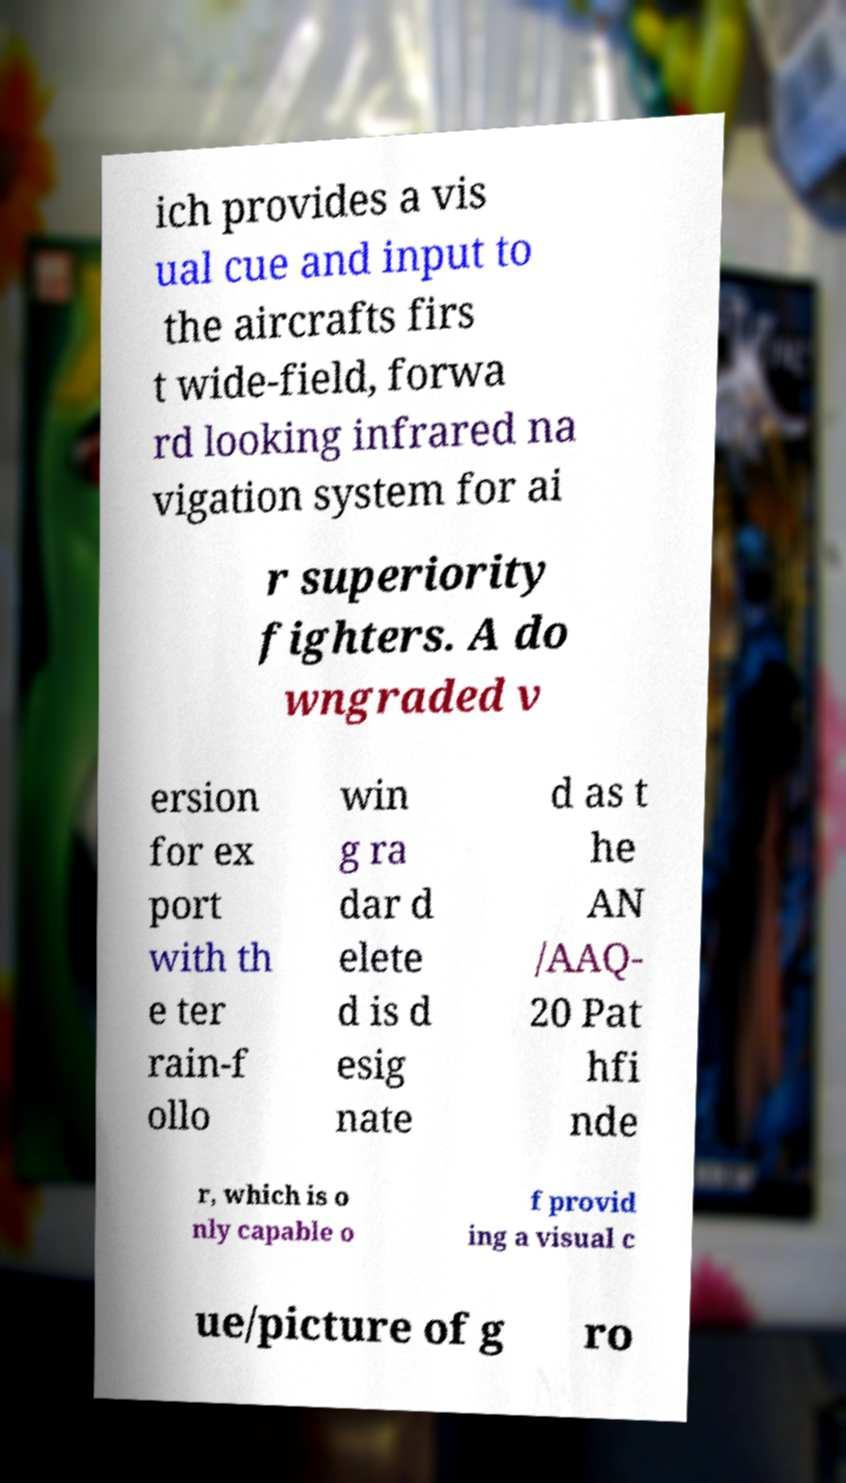Could you assist in decoding the text presented in this image and type it out clearly? ich provides a vis ual cue and input to the aircrafts firs t wide-field, forwa rd looking infrared na vigation system for ai r superiority fighters. A do wngraded v ersion for ex port with th e ter rain-f ollo win g ra dar d elete d is d esig nate d as t he AN /AAQ- 20 Pat hfi nde r, which is o nly capable o f provid ing a visual c ue/picture of g ro 